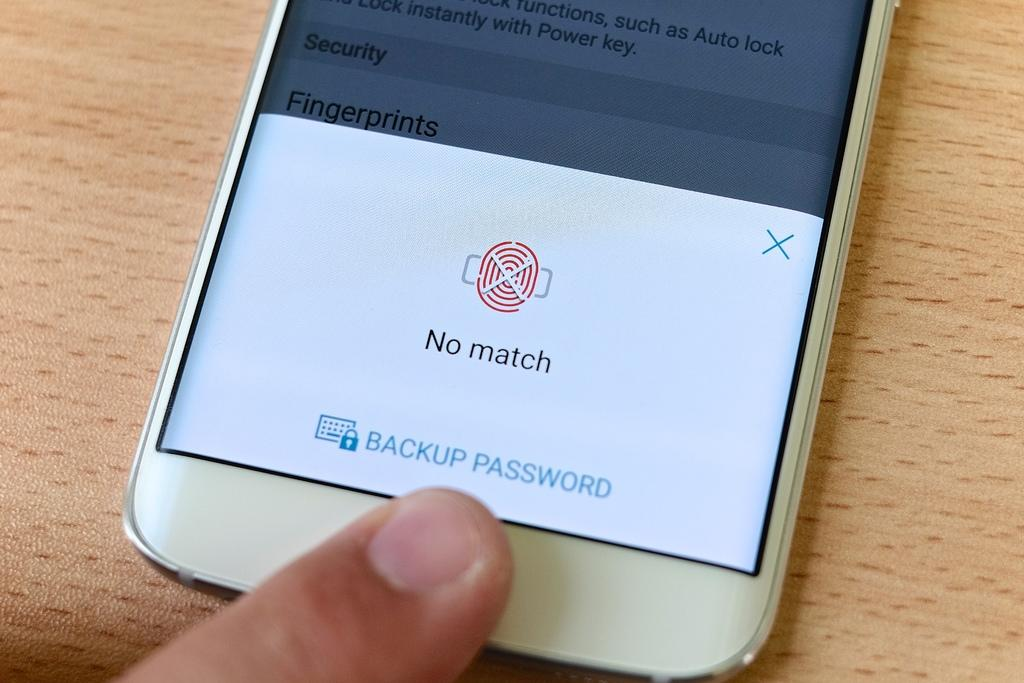<image>
Present a compact description of the photo's key features. An electronic device showing that the fingerprint was not a match and asking for a backup password. 